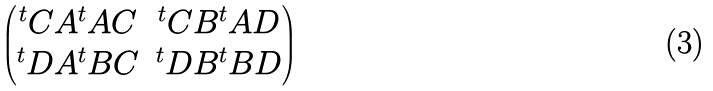<formula> <loc_0><loc_0><loc_500><loc_500>\begin{pmatrix} ^ { t } C A ^ { t } A C & ^ { t } C B ^ { t } A D \\ ^ { t } D A ^ { t } B C & ^ { t } D B ^ { t } B D \end{pmatrix}</formula> 